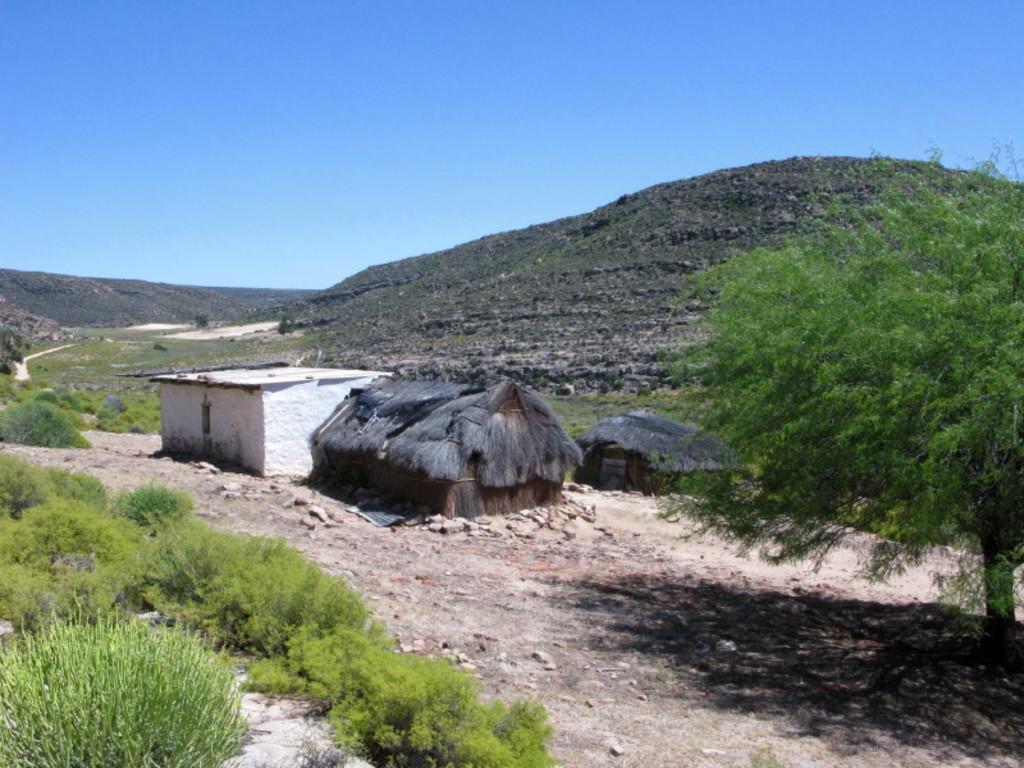In one or two sentences, can you explain what this image depicts? In this picture I can observe huts in the middle of the picture. On the right side I can observe a tree. On the left side I can observe some plants on the ground. In the background I can observe hill and sky. 